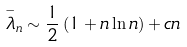Convert formula to latex. <formula><loc_0><loc_0><loc_500><loc_500>\overset { - } { \lambda } _ { n } \sim \frac { 1 } { 2 } \left ( 1 + n \ln n \right ) + c n</formula> 